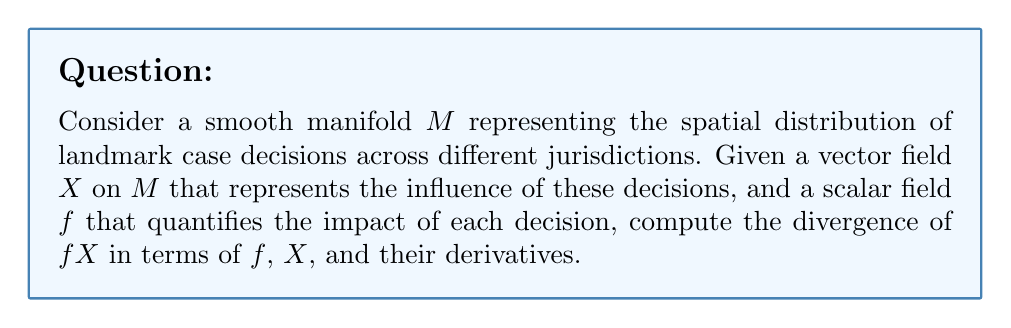Can you solve this math problem? To solve this problem, we'll use the properties of divergence and the product rule for vector fields. Let's proceed step-by-step:

1) The divergence of a product of a scalar field and a vector field is given by:

   $$\text{div}(fX) = f \cdot \text{div}(X) + X(f)$$

   where $X(f)$ is the directional derivative of $f$ along $X$.

2) In local coordinates $(x^1, \ldots, x^n)$ on the manifold $M$, we can express the vector field $X$ as:

   $$X = \sum_{i=1}^n X^i \frac{\partial}{\partial x^i}$$

3) The divergence of $X$ in these coordinates is:

   $$\text{div}(X) = \frac{1}{\sqrt{|g|}} \frac{\partial}{\partial x^i}(\sqrt{|g|}X^i)$$

   where $g$ is the metric tensor and $|g|$ is its determinant.

4) The directional derivative $X(f)$ can be written as:

   $$X(f) = \sum_{i=1}^n X^i \frac{\partial f}{\partial x^i}$$

5) Substituting these expressions into the formula from step 1:

   $$\text{div}(fX) = f \cdot \frac{1}{\sqrt{|g|}} \frac{\partial}{\partial x^i}(\sqrt{|g|}X^i) + \sum_{i=1}^n X^i \frac{\partial f}{\partial x^i}$$

6) This can be rewritten as:

   $$\text{div}(fX) = \frac{1}{\sqrt{|g|}} \frac{\partial}{\partial x^i}(f\sqrt{|g|}X^i)$$

This final expression gives us the divergence of $fX$ in terms of $f$, $X$, and their derivatives on the manifold $M$.
Answer: $$\text{div}(fX) = \frac{1}{\sqrt{|g|}} \frac{\partial}{\partial x^i}(f\sqrt{|g|}X^i)$$ 